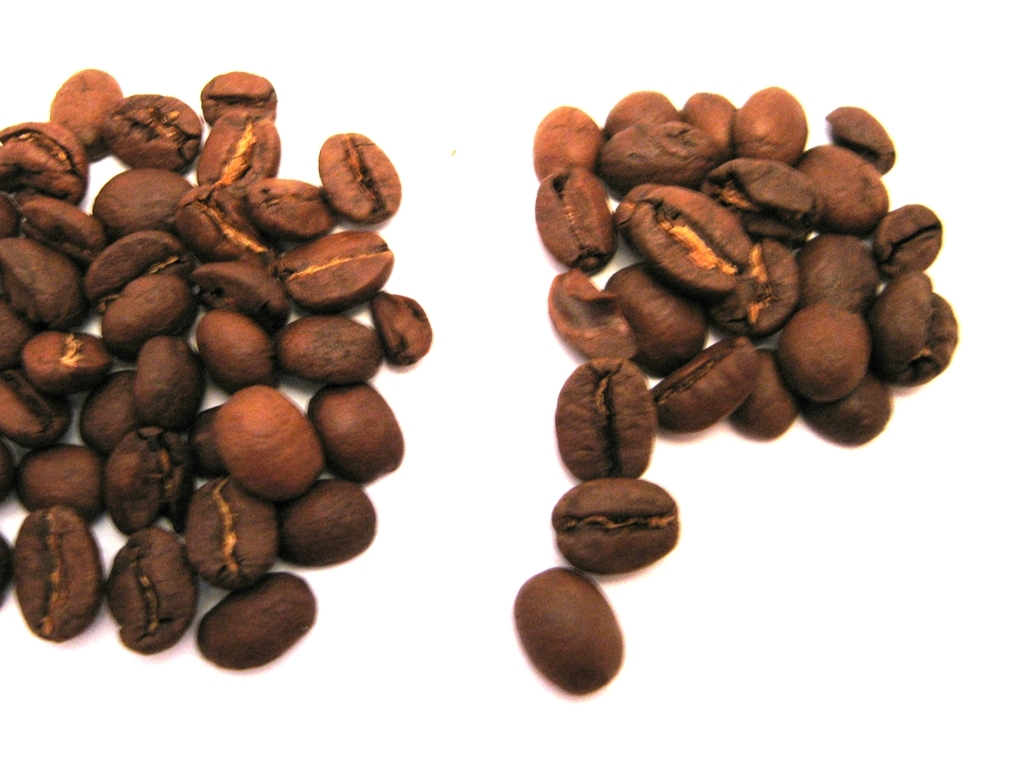Are there any color inaccuracies in this image?
A. No
B. Yes
Answer with the option's letter from the given choices directly.
 A. 